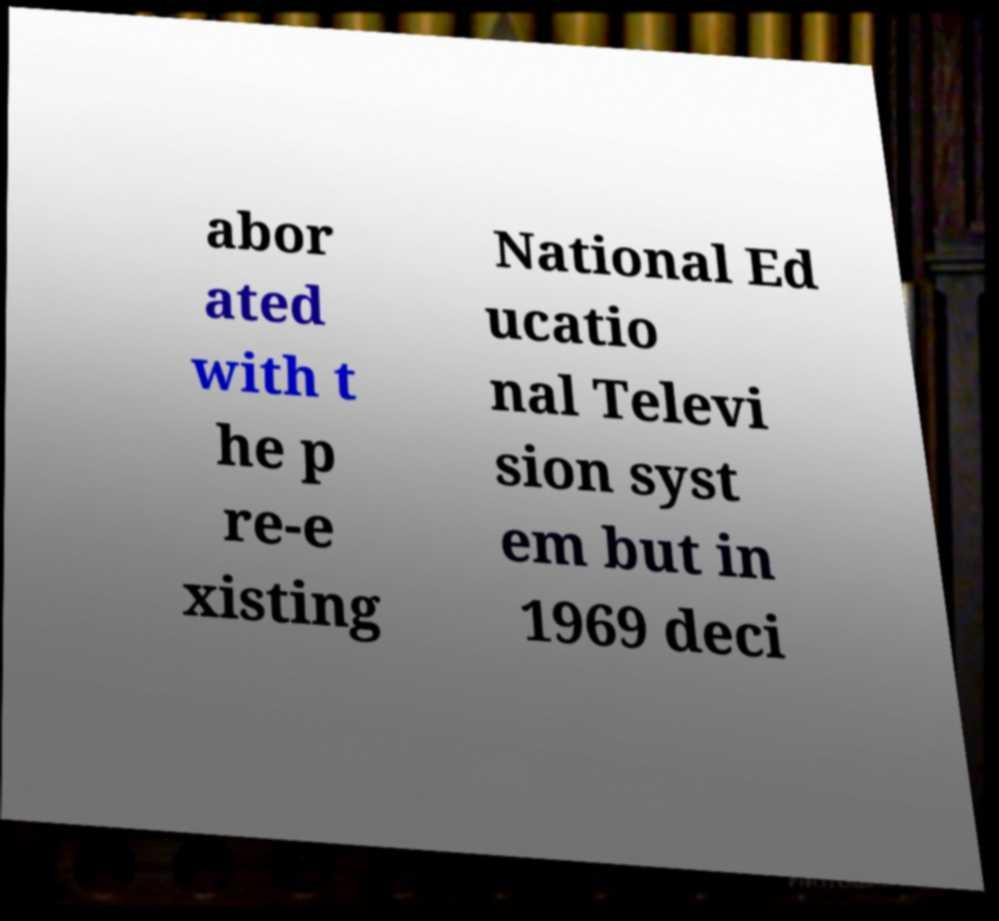Could you extract and type out the text from this image? abor ated with t he p re-e xisting National Ed ucatio nal Televi sion syst em but in 1969 deci 